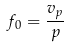<formula> <loc_0><loc_0><loc_500><loc_500>f _ { 0 } = \frac { v _ { p } } { p }</formula> 